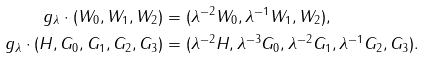Convert formula to latex. <formula><loc_0><loc_0><loc_500><loc_500>g _ { \lambda } \cdot ( W _ { 0 } , W _ { 1 } , W _ { 2 } ) & = ( \lambda ^ { - 2 } W _ { 0 } , \lambda ^ { - 1 } W _ { 1 } , W _ { 2 } ) , \\ g _ { \lambda } \cdot ( H , G _ { 0 } , G _ { 1 } , G _ { 2 } , G _ { 3 } ) & = ( \lambda ^ { - 2 } H , \lambda ^ { - 3 } G _ { 0 } , \lambda ^ { - 2 } G _ { 1 } , \lambda ^ { - 1 } G _ { 2 } , G _ { 3 } ) .</formula> 